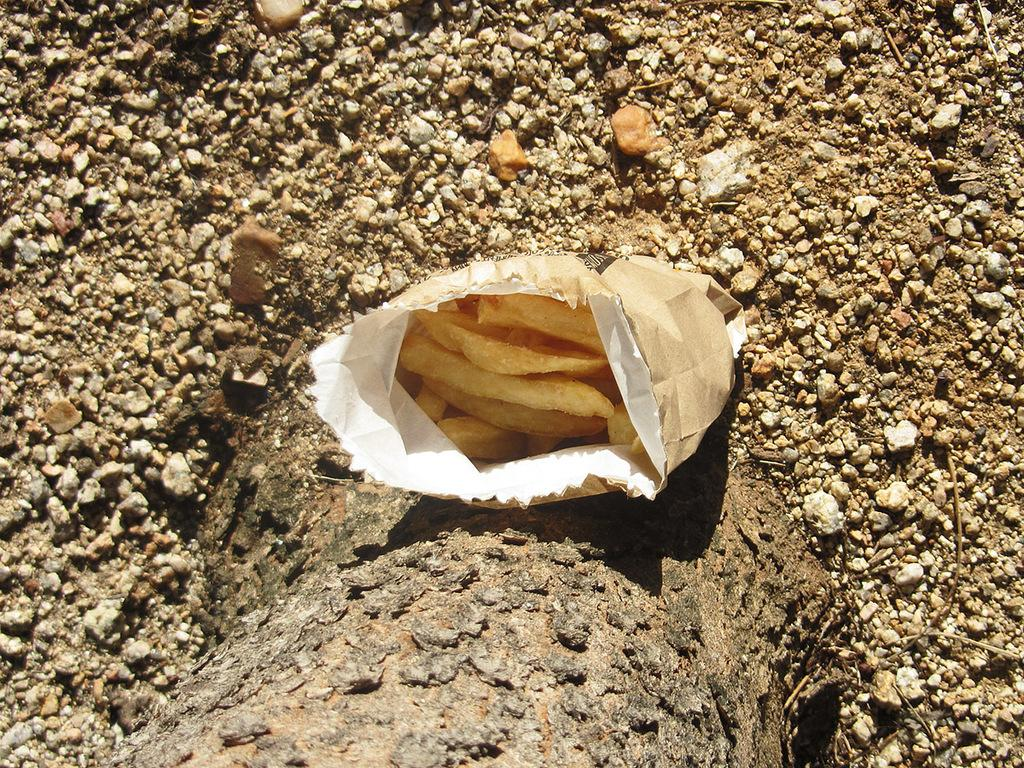What is in the paper cup that is visible in the image? There are chips in a paper cup in the image. What is the condition of the cup's cover? The cover of the cup is on the ground. What else can be seen on the ground in the image? There are stones on the ground. What decision led to the death of the person in the image? There is no person present in the image, and therefore no decision or death can be observed. 